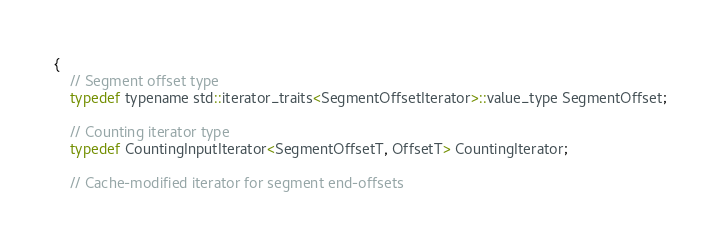<code> <loc_0><loc_0><loc_500><loc_500><_Cuda_>{
    // Segment offset type
    typedef typename std::iterator_traits<SegmentOffsetIterator>::value_type SegmentOffset;

    // Counting iterator type
    typedef CountingInputIterator<SegmentOffsetT, OffsetT> CountingIterator;

    // Cache-modified iterator for segment end-offsets</code> 